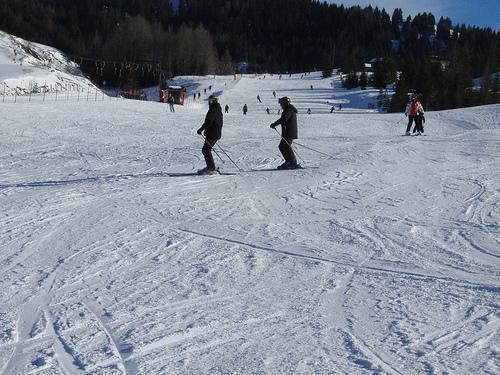How many poles do you see in the picture?
Give a very brief answer. 4. How many people are on the ski lift?
Give a very brief answer. 0. 